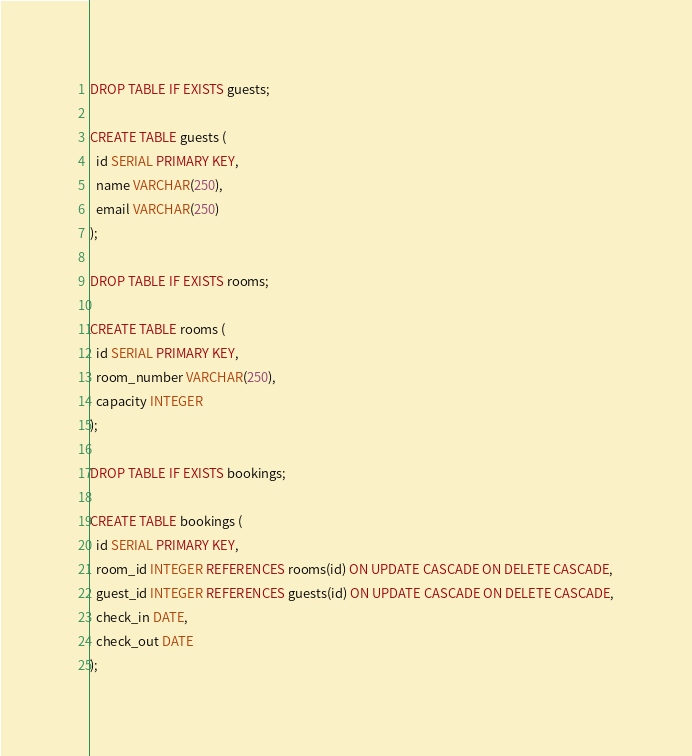<code> <loc_0><loc_0><loc_500><loc_500><_SQL_>DROP TABLE IF EXISTS guests;

CREATE TABLE guests (
  id SERIAL PRIMARY KEY,
  name VARCHAR(250),
  email VARCHAR(250)
);

DROP TABLE IF EXISTS rooms;

CREATE TABLE rooms (
  id SERIAL PRIMARY KEY,
  room_number VARCHAR(250),
  capacity INTEGER
);

DROP TABLE IF EXISTS bookings;

CREATE TABLE bookings (
  id SERIAL PRIMARY KEY,
  room_id INTEGER REFERENCES rooms(id) ON UPDATE CASCADE ON DELETE CASCADE,
  guest_id INTEGER REFERENCES guests(id) ON UPDATE CASCADE ON DELETE CASCADE,
  check_in DATE,
  check_out DATE
);
</code> 